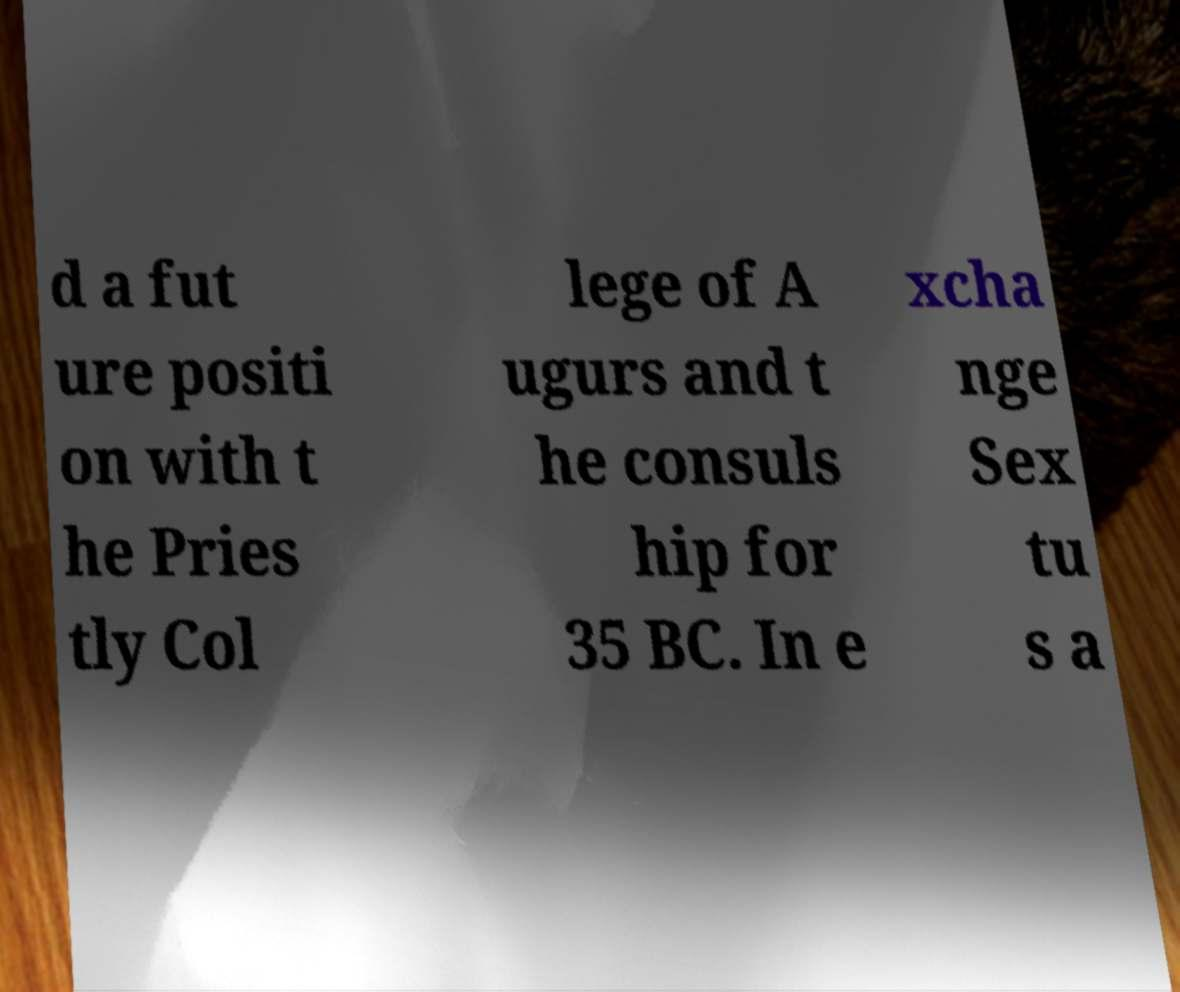I need the written content from this picture converted into text. Can you do that? d a fut ure positi on with t he Pries tly Col lege of A ugurs and t he consuls hip for 35 BC. In e xcha nge Sex tu s a 